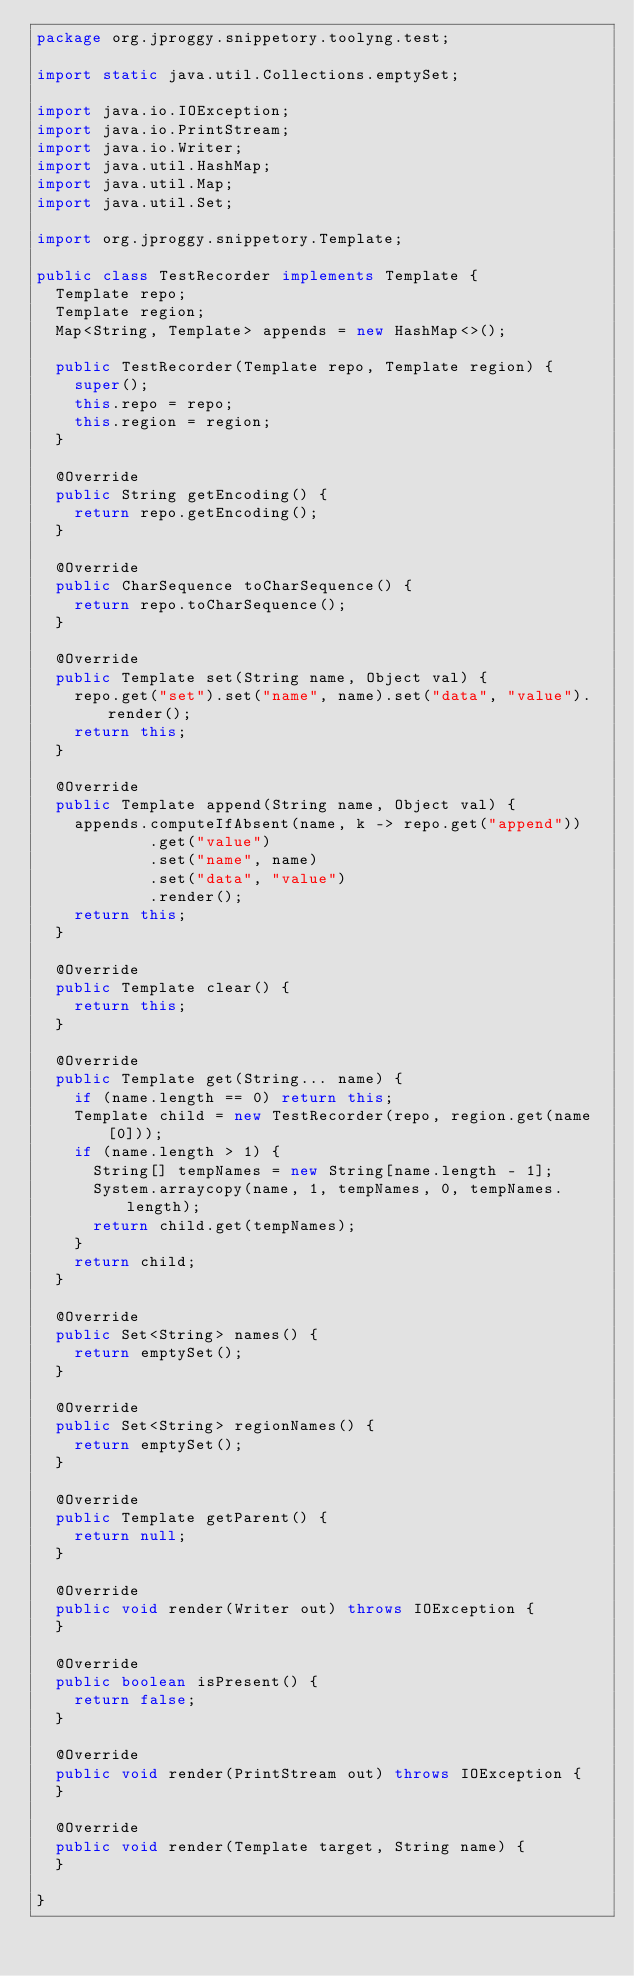<code> <loc_0><loc_0><loc_500><loc_500><_Java_>package org.jproggy.snippetory.toolyng.test;

import static java.util.Collections.emptySet;

import java.io.IOException;
import java.io.PrintStream;
import java.io.Writer;
import java.util.HashMap;
import java.util.Map;
import java.util.Set;

import org.jproggy.snippetory.Template;

public class TestRecorder implements Template {
  Template repo;
  Template region;
  Map<String, Template> appends = new HashMap<>();

  public TestRecorder(Template repo, Template region) {
    super();
    this.repo = repo;
    this.region = region;
  }

  @Override
  public String getEncoding() {
    return repo.getEncoding();
  }

  @Override
  public CharSequence toCharSequence() {
    return repo.toCharSequence();
  }

  @Override
  public Template set(String name, Object val) {
    repo.get("set").set("name", name).set("data", "value").render();
    return this;
  }

  @Override
  public Template append(String name, Object val) {
    appends.computeIfAbsent(name, k -> repo.get("append"))
            .get("value")
            .set("name", name)
            .set("data", "value")
            .render();
    return this;
  }

  @Override
  public Template clear() {
    return this;
  }

  @Override
  public Template get(String... name) {
    if (name.length == 0) return this;
    Template child = new TestRecorder(repo, region.get(name[0]));
    if (name.length > 1) {
      String[] tempNames = new String[name.length - 1];
      System.arraycopy(name, 1, tempNames, 0, tempNames.length);
      return child.get(tempNames);
    }
    return child;
  }

  @Override
  public Set<String> names() {
    return emptySet();
  }

  @Override
  public Set<String> regionNames() {
    return emptySet();
  }

  @Override
  public Template getParent() {
    return null;
  }

  @Override
  public void render(Writer out) throws IOException {
  }

  @Override
  public boolean isPresent() {
    return false;
  }

  @Override
  public void render(PrintStream out) throws IOException {
  }

  @Override
  public void render(Template target, String name) {
  }

}
</code> 